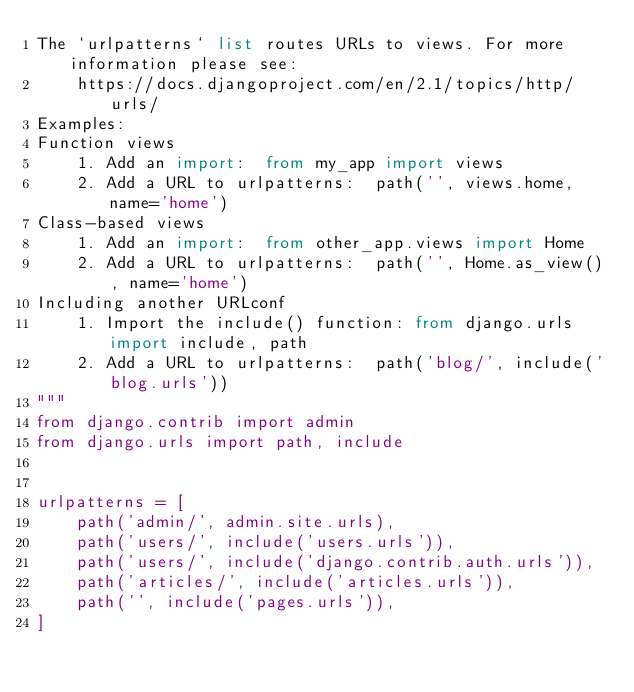<code> <loc_0><loc_0><loc_500><loc_500><_Python_>The `urlpatterns` list routes URLs to views. For more information please see:
    https://docs.djangoproject.com/en/2.1/topics/http/urls/
Examples:
Function views
    1. Add an import:  from my_app import views
    2. Add a URL to urlpatterns:  path('', views.home, name='home')
Class-based views
    1. Add an import:  from other_app.views import Home
    2. Add a URL to urlpatterns:  path('', Home.as_view(), name='home')
Including another URLconf
    1. Import the include() function: from django.urls import include, path
    2. Add a URL to urlpatterns:  path('blog/', include('blog.urls'))
"""
from django.contrib import admin
from django.urls import path, include


urlpatterns = [
    path('admin/', admin.site.urls),
    path('users/', include('users.urls')),
    path('users/', include('django.contrib.auth.urls')),
    path('articles/', include('articles.urls')),
    path('', include('pages.urls')),
]
</code> 